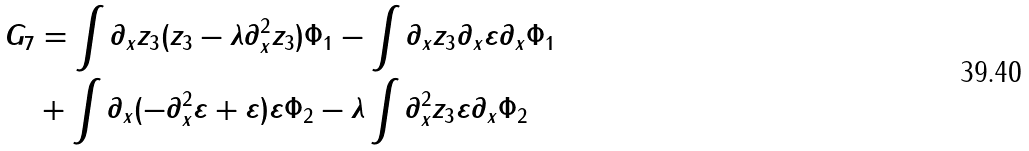Convert formula to latex. <formula><loc_0><loc_0><loc_500><loc_500>G _ { 7 } & = \int \partial _ { x } z _ { 3 } ( z _ { 3 } - \lambda \partial _ { x } ^ { 2 } z _ { 3 } ) \Phi _ { 1 } - \int \partial _ { x } z _ { 3 } \partial _ { x } \varepsilon \partial _ { x } \Phi _ { 1 } \\ & + \int \partial _ { x } ( - \partial _ { x } ^ { 2 } \varepsilon + \varepsilon ) \varepsilon \Phi _ { 2 } - \lambda \int \partial ^ { 2 } _ { x } z _ { 3 } \varepsilon \partial _ { x } \Phi _ { 2 }</formula> 